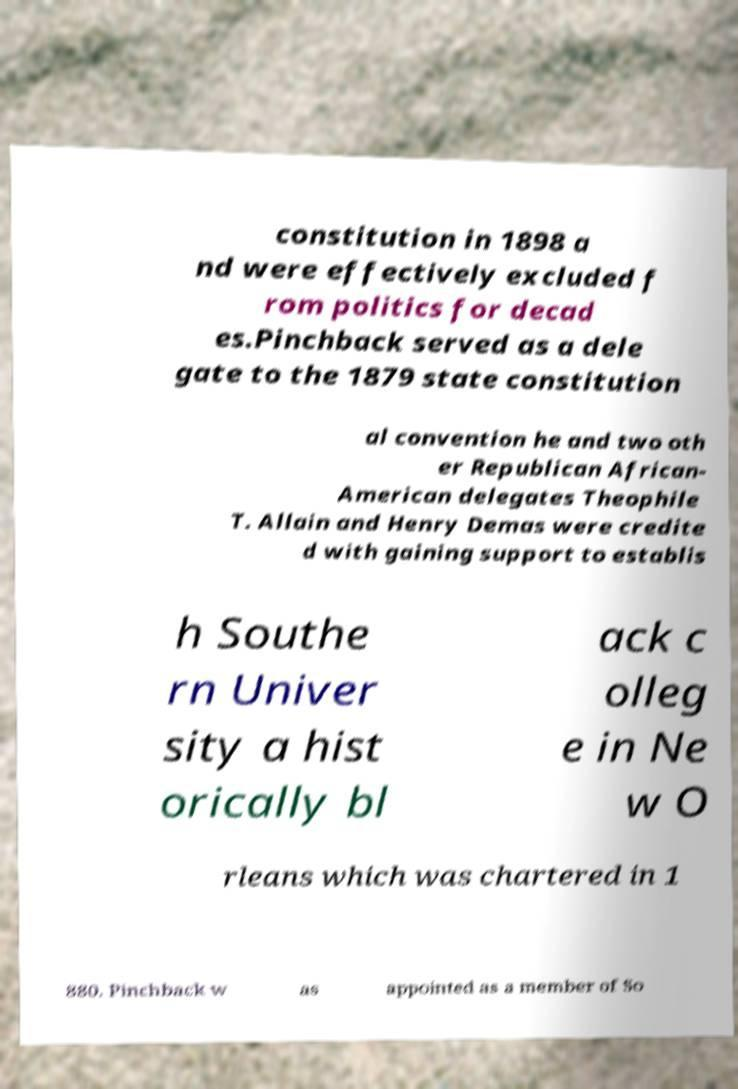Can you accurately transcribe the text from the provided image for me? constitution in 1898 a nd were effectively excluded f rom politics for decad es.Pinchback served as a dele gate to the 1879 state constitution al convention he and two oth er Republican African- American delegates Theophile T. Allain and Henry Demas were credite d with gaining support to establis h Southe rn Univer sity a hist orically bl ack c olleg e in Ne w O rleans which was chartered in 1 880. Pinchback w as appointed as a member of So 